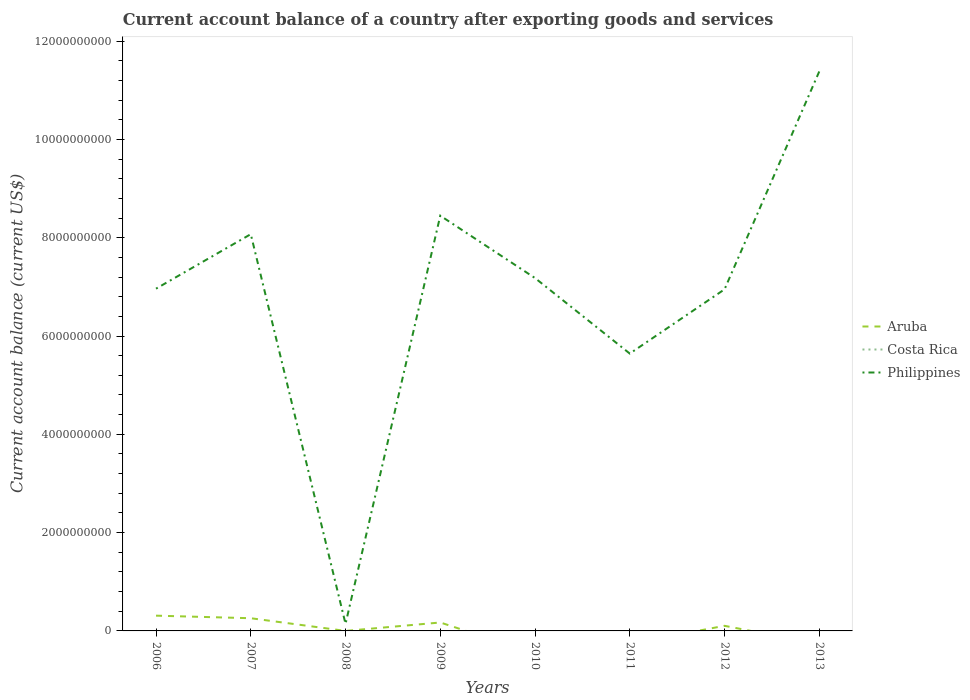How many different coloured lines are there?
Your response must be concise. 2. Does the line corresponding to Aruba intersect with the line corresponding to Costa Rica?
Offer a very short reply. No. What is the total account balance in Philippines in the graph?
Your response must be concise. -2.94e+09. What is the difference between the highest and the second highest account balance in Aruba?
Offer a very short reply. 3.11e+08. What is the difference between the highest and the lowest account balance in Aruba?
Provide a short and direct response. 3. How many lines are there?
Provide a succinct answer. 2. What is the difference between two consecutive major ticks on the Y-axis?
Offer a very short reply. 2.00e+09. Does the graph contain grids?
Your answer should be very brief. No. Where does the legend appear in the graph?
Make the answer very short. Center right. How are the legend labels stacked?
Your answer should be very brief. Vertical. What is the title of the graph?
Ensure brevity in your answer.  Current account balance of a country after exporting goods and services. What is the label or title of the Y-axis?
Your response must be concise. Current account balance (current US$). What is the Current account balance (current US$) in Aruba in 2006?
Provide a succinct answer. 3.11e+08. What is the Current account balance (current US$) of Philippines in 2006?
Your answer should be compact. 6.96e+09. What is the Current account balance (current US$) in Aruba in 2007?
Keep it short and to the point. 2.58e+08. What is the Current account balance (current US$) in Costa Rica in 2007?
Your response must be concise. 0. What is the Current account balance (current US$) in Philippines in 2007?
Your response must be concise. 8.07e+09. What is the Current account balance (current US$) in Aruba in 2008?
Offer a very short reply. 1.12e+05. What is the Current account balance (current US$) of Philippines in 2008?
Make the answer very short. 1.44e+08. What is the Current account balance (current US$) in Aruba in 2009?
Make the answer very short. 1.72e+08. What is the Current account balance (current US$) in Philippines in 2009?
Offer a terse response. 8.45e+09. What is the Current account balance (current US$) in Aruba in 2010?
Keep it short and to the point. 0. What is the Current account balance (current US$) of Costa Rica in 2010?
Offer a very short reply. 0. What is the Current account balance (current US$) in Philippines in 2010?
Your response must be concise. 7.18e+09. What is the Current account balance (current US$) in Philippines in 2011?
Provide a succinct answer. 5.64e+09. What is the Current account balance (current US$) in Aruba in 2012?
Your response must be concise. 1.04e+08. What is the Current account balance (current US$) in Costa Rica in 2012?
Provide a short and direct response. 0. What is the Current account balance (current US$) in Philippines in 2012?
Your response must be concise. 6.95e+09. What is the Current account balance (current US$) of Aruba in 2013?
Offer a very short reply. 0. What is the Current account balance (current US$) in Philippines in 2013?
Give a very brief answer. 1.14e+1. Across all years, what is the maximum Current account balance (current US$) of Aruba?
Your answer should be compact. 3.11e+08. Across all years, what is the maximum Current account balance (current US$) of Philippines?
Your answer should be very brief. 1.14e+1. Across all years, what is the minimum Current account balance (current US$) in Aruba?
Provide a short and direct response. 0. Across all years, what is the minimum Current account balance (current US$) of Philippines?
Give a very brief answer. 1.44e+08. What is the total Current account balance (current US$) of Aruba in the graph?
Your answer should be very brief. 8.45e+08. What is the total Current account balance (current US$) of Philippines in the graph?
Ensure brevity in your answer.  5.48e+1. What is the difference between the Current account balance (current US$) of Aruba in 2006 and that in 2007?
Your answer should be very brief. 5.23e+07. What is the difference between the Current account balance (current US$) of Philippines in 2006 and that in 2007?
Your answer should be very brief. -1.11e+09. What is the difference between the Current account balance (current US$) of Aruba in 2006 and that in 2008?
Your response must be concise. 3.10e+08. What is the difference between the Current account balance (current US$) of Philippines in 2006 and that in 2008?
Give a very brief answer. 6.82e+09. What is the difference between the Current account balance (current US$) in Aruba in 2006 and that in 2009?
Your answer should be compact. 1.39e+08. What is the difference between the Current account balance (current US$) of Philippines in 2006 and that in 2009?
Your answer should be very brief. -1.49e+09. What is the difference between the Current account balance (current US$) in Philippines in 2006 and that in 2010?
Your answer should be compact. -2.16e+08. What is the difference between the Current account balance (current US$) of Philippines in 2006 and that in 2011?
Keep it short and to the point. 1.32e+09. What is the difference between the Current account balance (current US$) in Aruba in 2006 and that in 2012?
Offer a very short reply. 2.07e+08. What is the difference between the Current account balance (current US$) of Philippines in 2006 and that in 2012?
Provide a short and direct response. 1.34e+07. What is the difference between the Current account balance (current US$) of Philippines in 2006 and that in 2013?
Provide a short and direct response. -4.42e+09. What is the difference between the Current account balance (current US$) in Aruba in 2007 and that in 2008?
Offer a very short reply. 2.58e+08. What is the difference between the Current account balance (current US$) in Philippines in 2007 and that in 2008?
Your answer should be compact. 7.93e+09. What is the difference between the Current account balance (current US$) of Aruba in 2007 and that in 2009?
Offer a terse response. 8.66e+07. What is the difference between the Current account balance (current US$) of Philippines in 2007 and that in 2009?
Keep it short and to the point. -3.76e+08. What is the difference between the Current account balance (current US$) of Philippines in 2007 and that in 2010?
Keep it short and to the point. 8.93e+08. What is the difference between the Current account balance (current US$) of Philippines in 2007 and that in 2011?
Provide a succinct answer. 2.43e+09. What is the difference between the Current account balance (current US$) of Aruba in 2007 and that in 2012?
Provide a short and direct response. 1.54e+08. What is the difference between the Current account balance (current US$) of Philippines in 2007 and that in 2012?
Give a very brief answer. 1.12e+09. What is the difference between the Current account balance (current US$) of Philippines in 2007 and that in 2013?
Your answer should be very brief. -3.31e+09. What is the difference between the Current account balance (current US$) in Aruba in 2008 and that in 2009?
Give a very brief answer. -1.72e+08. What is the difference between the Current account balance (current US$) of Philippines in 2008 and that in 2009?
Offer a terse response. -8.30e+09. What is the difference between the Current account balance (current US$) in Philippines in 2008 and that in 2010?
Keep it short and to the point. -7.04e+09. What is the difference between the Current account balance (current US$) of Philippines in 2008 and that in 2011?
Keep it short and to the point. -5.50e+09. What is the difference between the Current account balance (current US$) in Aruba in 2008 and that in 2012?
Make the answer very short. -1.04e+08. What is the difference between the Current account balance (current US$) in Philippines in 2008 and that in 2012?
Offer a very short reply. -6.81e+09. What is the difference between the Current account balance (current US$) in Philippines in 2008 and that in 2013?
Make the answer very short. -1.12e+1. What is the difference between the Current account balance (current US$) of Philippines in 2009 and that in 2010?
Offer a terse response. 1.27e+09. What is the difference between the Current account balance (current US$) of Philippines in 2009 and that in 2011?
Give a very brief answer. 2.81e+09. What is the difference between the Current account balance (current US$) in Aruba in 2009 and that in 2012?
Provide a short and direct response. 6.77e+07. What is the difference between the Current account balance (current US$) in Philippines in 2009 and that in 2012?
Provide a short and direct response. 1.50e+09. What is the difference between the Current account balance (current US$) of Philippines in 2009 and that in 2013?
Offer a very short reply. -2.94e+09. What is the difference between the Current account balance (current US$) of Philippines in 2010 and that in 2011?
Your answer should be compact. 1.54e+09. What is the difference between the Current account balance (current US$) of Philippines in 2010 and that in 2012?
Your answer should be compact. 2.30e+08. What is the difference between the Current account balance (current US$) of Philippines in 2010 and that in 2013?
Your answer should be compact. -4.20e+09. What is the difference between the Current account balance (current US$) in Philippines in 2011 and that in 2012?
Provide a succinct answer. -1.31e+09. What is the difference between the Current account balance (current US$) of Philippines in 2011 and that in 2013?
Offer a very short reply. -5.74e+09. What is the difference between the Current account balance (current US$) in Philippines in 2012 and that in 2013?
Provide a short and direct response. -4.43e+09. What is the difference between the Current account balance (current US$) in Aruba in 2006 and the Current account balance (current US$) in Philippines in 2007?
Your answer should be compact. -7.76e+09. What is the difference between the Current account balance (current US$) of Aruba in 2006 and the Current account balance (current US$) of Philippines in 2008?
Offer a terse response. 1.67e+08. What is the difference between the Current account balance (current US$) of Aruba in 2006 and the Current account balance (current US$) of Philippines in 2009?
Offer a terse response. -8.14e+09. What is the difference between the Current account balance (current US$) of Aruba in 2006 and the Current account balance (current US$) of Philippines in 2010?
Your answer should be very brief. -6.87e+09. What is the difference between the Current account balance (current US$) in Aruba in 2006 and the Current account balance (current US$) in Philippines in 2011?
Provide a succinct answer. -5.33e+09. What is the difference between the Current account balance (current US$) in Aruba in 2006 and the Current account balance (current US$) in Philippines in 2012?
Keep it short and to the point. -6.64e+09. What is the difference between the Current account balance (current US$) of Aruba in 2006 and the Current account balance (current US$) of Philippines in 2013?
Ensure brevity in your answer.  -1.11e+1. What is the difference between the Current account balance (current US$) in Aruba in 2007 and the Current account balance (current US$) in Philippines in 2008?
Offer a terse response. 1.14e+08. What is the difference between the Current account balance (current US$) in Aruba in 2007 and the Current account balance (current US$) in Philippines in 2009?
Provide a succinct answer. -8.19e+09. What is the difference between the Current account balance (current US$) in Aruba in 2007 and the Current account balance (current US$) in Philippines in 2010?
Give a very brief answer. -6.92e+09. What is the difference between the Current account balance (current US$) in Aruba in 2007 and the Current account balance (current US$) in Philippines in 2011?
Your answer should be very brief. -5.38e+09. What is the difference between the Current account balance (current US$) of Aruba in 2007 and the Current account balance (current US$) of Philippines in 2012?
Your answer should be very brief. -6.69e+09. What is the difference between the Current account balance (current US$) in Aruba in 2007 and the Current account balance (current US$) in Philippines in 2013?
Ensure brevity in your answer.  -1.11e+1. What is the difference between the Current account balance (current US$) of Aruba in 2008 and the Current account balance (current US$) of Philippines in 2009?
Offer a terse response. -8.45e+09. What is the difference between the Current account balance (current US$) in Aruba in 2008 and the Current account balance (current US$) in Philippines in 2010?
Keep it short and to the point. -7.18e+09. What is the difference between the Current account balance (current US$) of Aruba in 2008 and the Current account balance (current US$) of Philippines in 2011?
Provide a short and direct response. -5.64e+09. What is the difference between the Current account balance (current US$) in Aruba in 2008 and the Current account balance (current US$) in Philippines in 2012?
Make the answer very short. -6.95e+09. What is the difference between the Current account balance (current US$) of Aruba in 2008 and the Current account balance (current US$) of Philippines in 2013?
Your response must be concise. -1.14e+1. What is the difference between the Current account balance (current US$) of Aruba in 2009 and the Current account balance (current US$) of Philippines in 2010?
Your answer should be very brief. -7.01e+09. What is the difference between the Current account balance (current US$) in Aruba in 2009 and the Current account balance (current US$) in Philippines in 2011?
Offer a terse response. -5.47e+09. What is the difference between the Current account balance (current US$) in Aruba in 2009 and the Current account balance (current US$) in Philippines in 2012?
Your answer should be compact. -6.78e+09. What is the difference between the Current account balance (current US$) in Aruba in 2009 and the Current account balance (current US$) in Philippines in 2013?
Provide a short and direct response. -1.12e+1. What is the difference between the Current account balance (current US$) of Aruba in 2012 and the Current account balance (current US$) of Philippines in 2013?
Give a very brief answer. -1.13e+1. What is the average Current account balance (current US$) in Aruba per year?
Your response must be concise. 1.06e+08. What is the average Current account balance (current US$) of Costa Rica per year?
Ensure brevity in your answer.  0. What is the average Current account balance (current US$) of Philippines per year?
Give a very brief answer. 6.85e+09. In the year 2006, what is the difference between the Current account balance (current US$) of Aruba and Current account balance (current US$) of Philippines?
Your answer should be very brief. -6.65e+09. In the year 2007, what is the difference between the Current account balance (current US$) of Aruba and Current account balance (current US$) of Philippines?
Ensure brevity in your answer.  -7.81e+09. In the year 2008, what is the difference between the Current account balance (current US$) of Aruba and Current account balance (current US$) of Philippines?
Your answer should be very brief. -1.44e+08. In the year 2009, what is the difference between the Current account balance (current US$) in Aruba and Current account balance (current US$) in Philippines?
Keep it short and to the point. -8.28e+09. In the year 2012, what is the difference between the Current account balance (current US$) in Aruba and Current account balance (current US$) in Philippines?
Give a very brief answer. -6.85e+09. What is the ratio of the Current account balance (current US$) of Aruba in 2006 to that in 2007?
Your response must be concise. 1.2. What is the ratio of the Current account balance (current US$) in Philippines in 2006 to that in 2007?
Your response must be concise. 0.86. What is the ratio of the Current account balance (current US$) in Aruba in 2006 to that in 2008?
Offer a very short reply. 2779.47. What is the ratio of the Current account balance (current US$) of Philippines in 2006 to that in 2008?
Offer a very short reply. 48.35. What is the ratio of the Current account balance (current US$) in Aruba in 2006 to that in 2009?
Your answer should be very brief. 1.81. What is the ratio of the Current account balance (current US$) of Philippines in 2006 to that in 2009?
Ensure brevity in your answer.  0.82. What is the ratio of the Current account balance (current US$) in Philippines in 2006 to that in 2010?
Give a very brief answer. 0.97. What is the ratio of the Current account balance (current US$) in Philippines in 2006 to that in 2011?
Provide a short and direct response. 1.23. What is the ratio of the Current account balance (current US$) of Aruba in 2006 to that in 2012?
Provide a succinct answer. 2.99. What is the ratio of the Current account balance (current US$) in Philippines in 2006 to that in 2013?
Ensure brevity in your answer.  0.61. What is the ratio of the Current account balance (current US$) in Aruba in 2007 to that in 2008?
Your answer should be very brief. 2311.5. What is the ratio of the Current account balance (current US$) in Philippines in 2007 to that in 2008?
Provide a short and direct response. 56.05. What is the ratio of the Current account balance (current US$) in Aruba in 2007 to that in 2009?
Your answer should be very brief. 1.5. What is the ratio of the Current account balance (current US$) of Philippines in 2007 to that in 2009?
Provide a short and direct response. 0.96. What is the ratio of the Current account balance (current US$) in Philippines in 2007 to that in 2010?
Provide a succinct answer. 1.12. What is the ratio of the Current account balance (current US$) of Philippines in 2007 to that in 2011?
Offer a very short reply. 1.43. What is the ratio of the Current account balance (current US$) in Aruba in 2007 to that in 2012?
Make the answer very short. 2.48. What is the ratio of the Current account balance (current US$) in Philippines in 2007 to that in 2012?
Give a very brief answer. 1.16. What is the ratio of the Current account balance (current US$) in Philippines in 2007 to that in 2013?
Keep it short and to the point. 0.71. What is the ratio of the Current account balance (current US$) in Aruba in 2008 to that in 2009?
Give a very brief answer. 0. What is the ratio of the Current account balance (current US$) in Philippines in 2008 to that in 2009?
Your answer should be compact. 0.02. What is the ratio of the Current account balance (current US$) in Philippines in 2008 to that in 2010?
Provide a succinct answer. 0.02. What is the ratio of the Current account balance (current US$) of Philippines in 2008 to that in 2011?
Keep it short and to the point. 0.03. What is the ratio of the Current account balance (current US$) in Aruba in 2008 to that in 2012?
Your answer should be very brief. 0. What is the ratio of the Current account balance (current US$) in Philippines in 2008 to that in 2012?
Your answer should be compact. 0.02. What is the ratio of the Current account balance (current US$) in Philippines in 2008 to that in 2013?
Your response must be concise. 0.01. What is the ratio of the Current account balance (current US$) in Philippines in 2009 to that in 2010?
Give a very brief answer. 1.18. What is the ratio of the Current account balance (current US$) in Philippines in 2009 to that in 2011?
Make the answer very short. 1.5. What is the ratio of the Current account balance (current US$) of Aruba in 2009 to that in 2012?
Offer a very short reply. 1.65. What is the ratio of the Current account balance (current US$) in Philippines in 2009 to that in 2012?
Give a very brief answer. 1.22. What is the ratio of the Current account balance (current US$) in Philippines in 2009 to that in 2013?
Provide a succinct answer. 0.74. What is the ratio of the Current account balance (current US$) in Philippines in 2010 to that in 2011?
Your answer should be very brief. 1.27. What is the ratio of the Current account balance (current US$) in Philippines in 2010 to that in 2012?
Keep it short and to the point. 1.03. What is the ratio of the Current account balance (current US$) in Philippines in 2010 to that in 2013?
Keep it short and to the point. 0.63. What is the ratio of the Current account balance (current US$) of Philippines in 2011 to that in 2012?
Offer a very short reply. 0.81. What is the ratio of the Current account balance (current US$) of Philippines in 2011 to that in 2013?
Provide a short and direct response. 0.5. What is the ratio of the Current account balance (current US$) of Philippines in 2012 to that in 2013?
Provide a short and direct response. 0.61. What is the difference between the highest and the second highest Current account balance (current US$) of Aruba?
Make the answer very short. 5.23e+07. What is the difference between the highest and the second highest Current account balance (current US$) in Philippines?
Provide a succinct answer. 2.94e+09. What is the difference between the highest and the lowest Current account balance (current US$) in Aruba?
Your response must be concise. 3.11e+08. What is the difference between the highest and the lowest Current account balance (current US$) of Philippines?
Keep it short and to the point. 1.12e+1. 